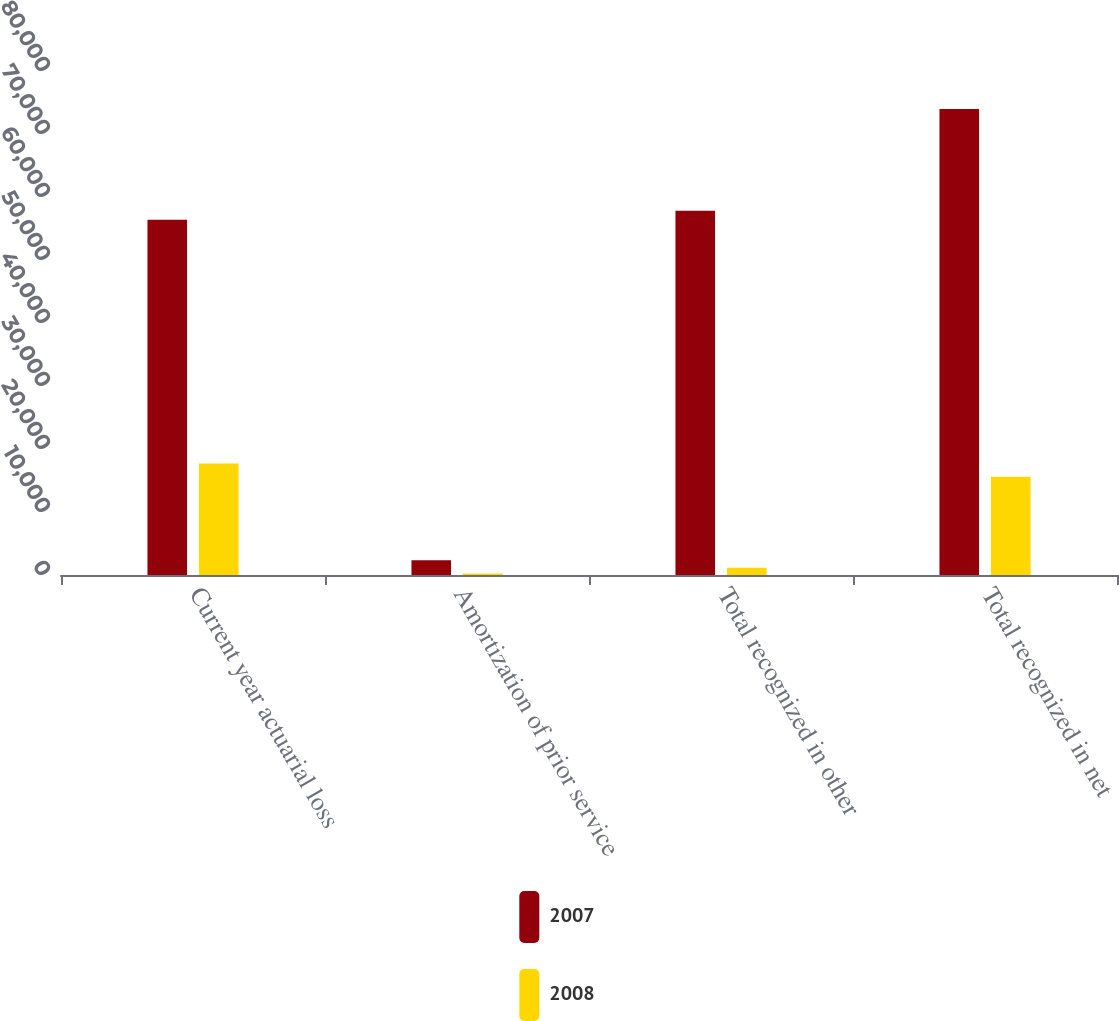Convert chart. <chart><loc_0><loc_0><loc_500><loc_500><stacked_bar_chart><ecel><fcel>Current year actuarial loss<fcel>Amortization of prior service<fcel>Total recognized in other<fcel>Total recognized in net<nl><fcel>2007<fcel>56386<fcel>2329<fcel>57813<fcel>73974<nl><fcel>2008<fcel>17705<fcel>229<fcel>1141<fcel>15603<nl></chart> 